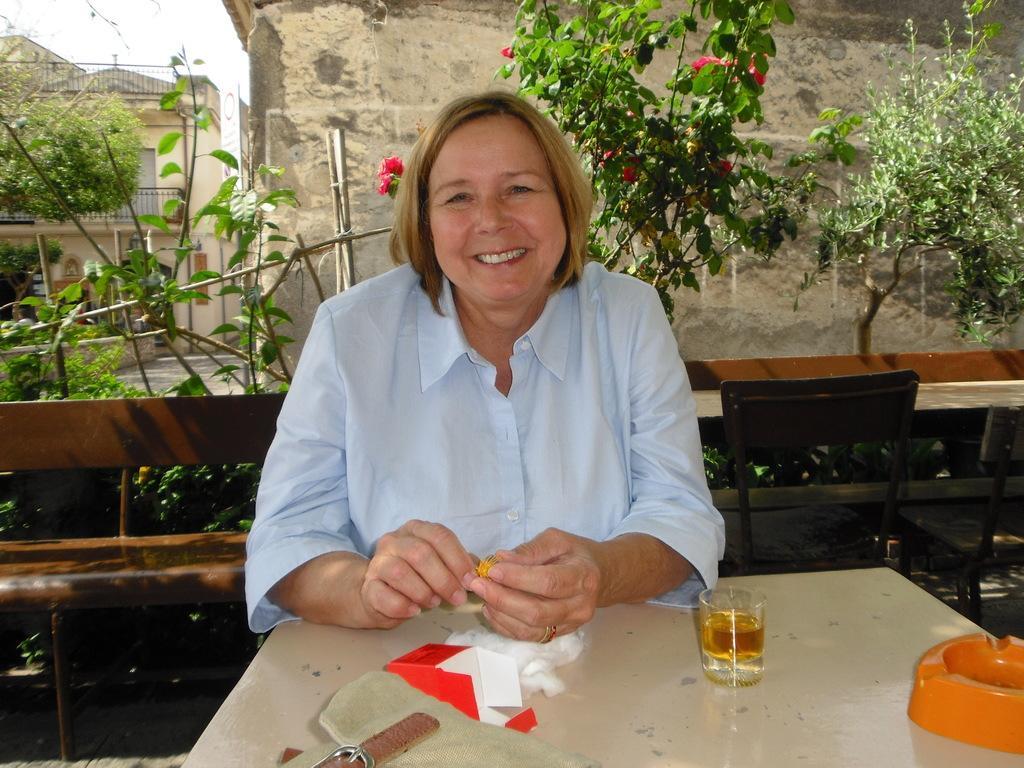How would you summarize this image in a sentence or two? In this picture a lady is sitting on a table on which a glass and a smoke holder is kept. In the background we can observe many trees and a rock in the background. We also find a small house in the top left corner of the image. 